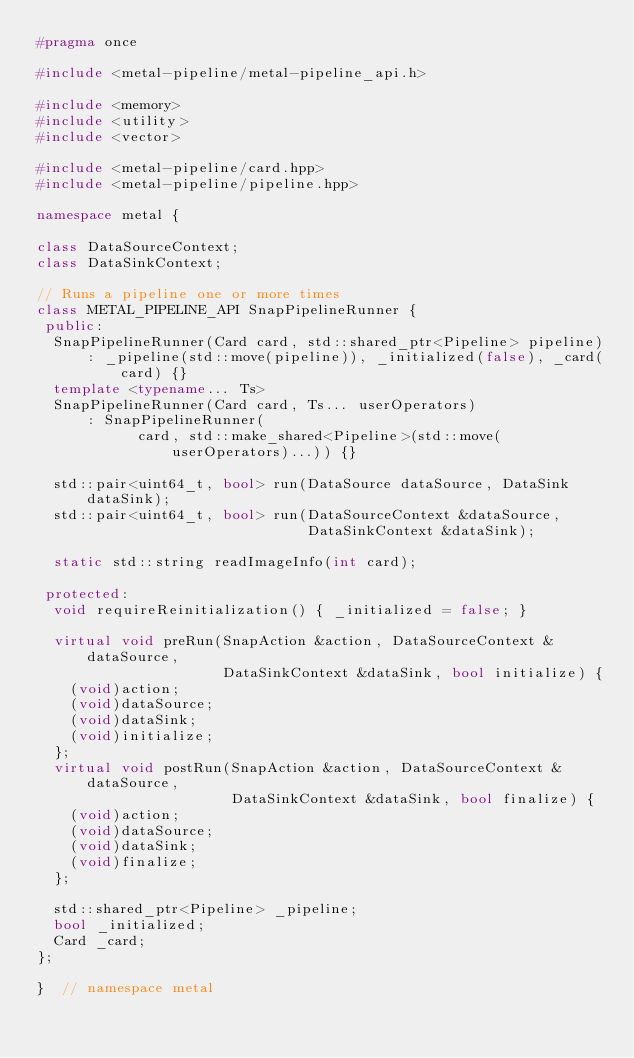Convert code to text. <code><loc_0><loc_0><loc_500><loc_500><_C++_>#pragma once

#include <metal-pipeline/metal-pipeline_api.h>

#include <memory>
#include <utility>
#include <vector>

#include <metal-pipeline/card.hpp>
#include <metal-pipeline/pipeline.hpp>

namespace metal {

class DataSourceContext;
class DataSinkContext;

// Runs a pipeline one or more times
class METAL_PIPELINE_API SnapPipelineRunner {
 public:
  SnapPipelineRunner(Card card, std::shared_ptr<Pipeline> pipeline)
      : _pipeline(std::move(pipeline)), _initialized(false), _card(card) {}
  template <typename... Ts>
  SnapPipelineRunner(Card card, Ts... userOperators)
      : SnapPipelineRunner(
            card, std::make_shared<Pipeline>(std::move(userOperators)...)) {}

  std::pair<uint64_t, bool> run(DataSource dataSource, DataSink dataSink);
  std::pair<uint64_t, bool> run(DataSourceContext &dataSource,
                                DataSinkContext &dataSink);

  static std::string readImageInfo(int card);

 protected:
  void requireReinitialization() { _initialized = false; }

  virtual void preRun(SnapAction &action, DataSourceContext &dataSource,
                      DataSinkContext &dataSink, bool initialize) {
    (void)action;
    (void)dataSource;
    (void)dataSink;
    (void)initialize;
  };
  virtual void postRun(SnapAction &action, DataSourceContext &dataSource,
                       DataSinkContext &dataSink, bool finalize) {
    (void)action;
    (void)dataSource;
    (void)dataSink;
    (void)finalize;
  };

  std::shared_ptr<Pipeline> _pipeline;
  bool _initialized;
  Card _card;
};

}  // namespace metal
</code> 